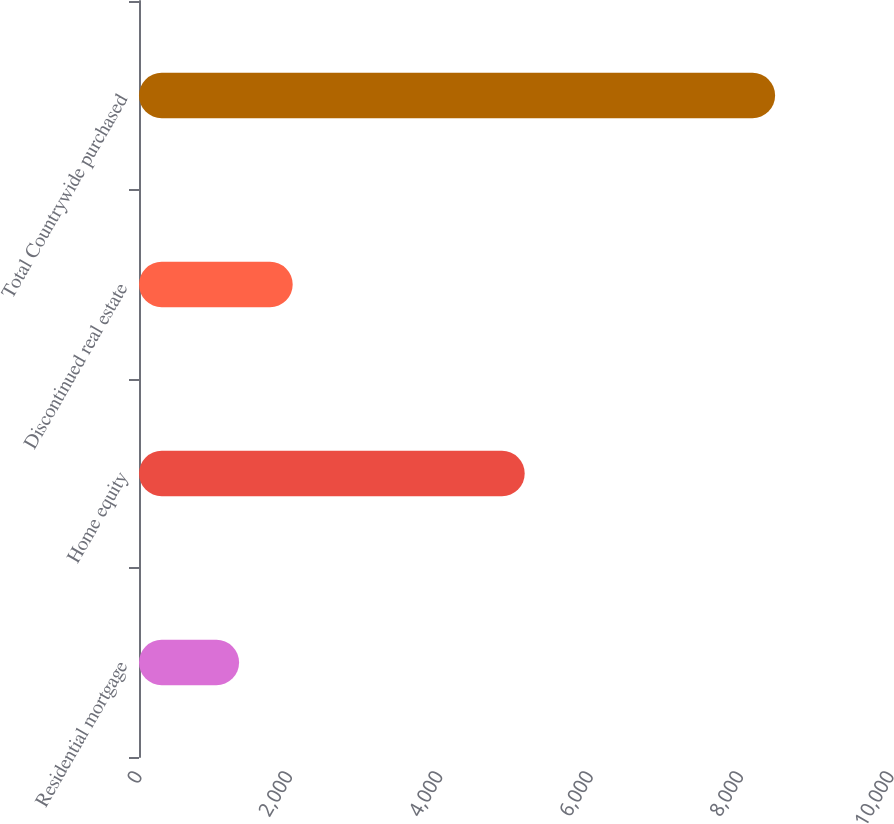Convert chart to OTSL. <chart><loc_0><loc_0><loc_500><loc_500><bar_chart><fcel>Residential mortgage<fcel>Home equity<fcel>Discontinued real estate<fcel>Total Countrywide purchased<nl><fcel>1331<fcel>5129<fcel>2043.8<fcel>8459<nl></chart> 